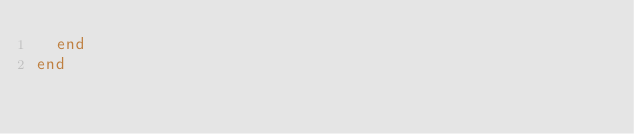<code> <loc_0><loc_0><loc_500><loc_500><_Ruby_>  end
end
</code> 